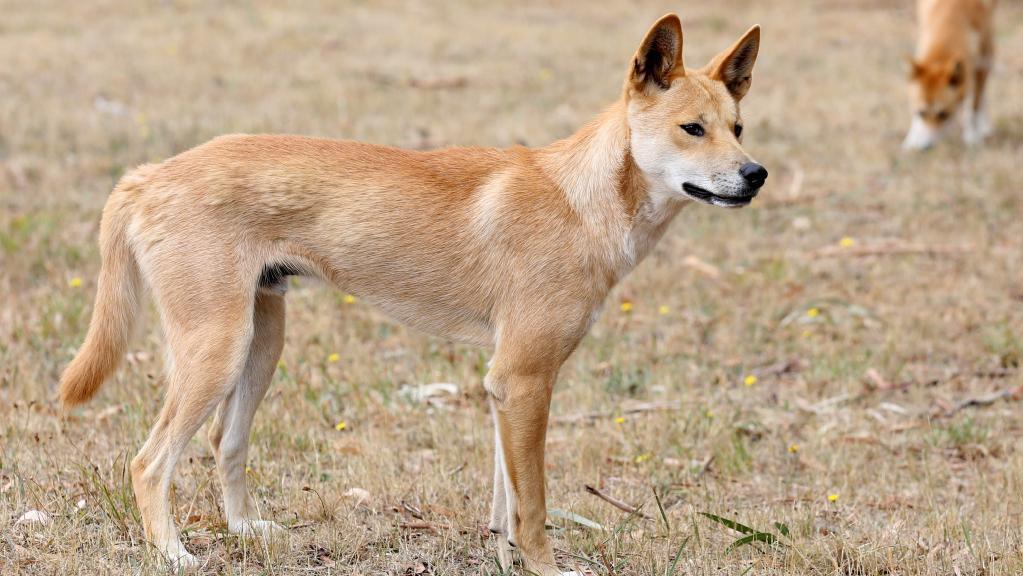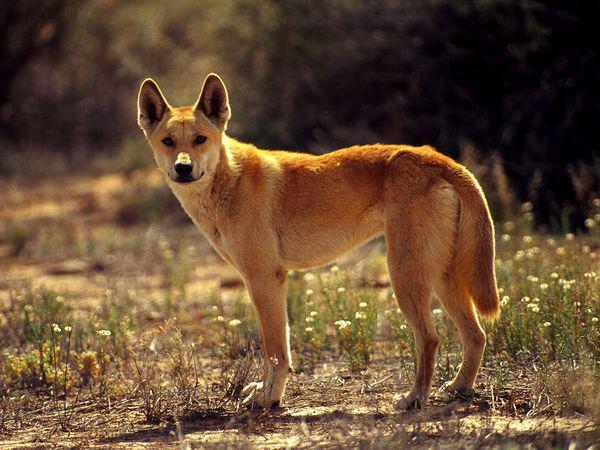The first image is the image on the left, the second image is the image on the right. Assess this claim about the two images: "There are exactly four animals in the pair of images with at least three of them standing.". Correct or not? Answer yes or no. No. The first image is the image on the left, the second image is the image on the right. Given the left and right images, does the statement "The combined images contain a total of four dingos, and at least three of the dogs are standing." hold true? Answer yes or no. No. 